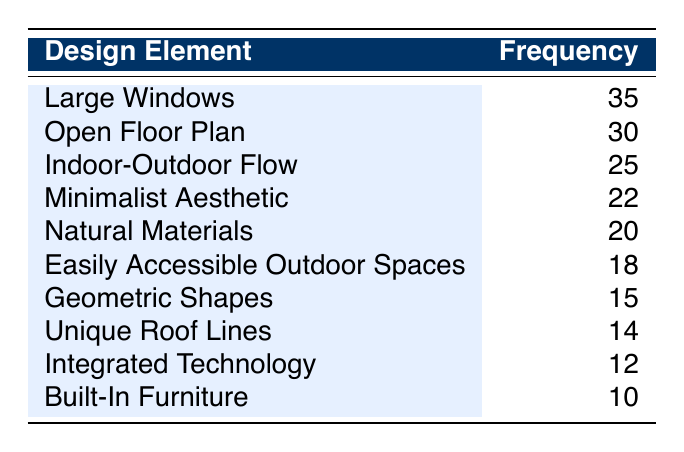What is the frequency of the design element "Large Windows"? The table shows that "Large Windows" has a frequency of 35, which is stated directly in the relevant row.
Answer: 35 Which design element has the lowest frequency? By looking at the table, "Built-In Furniture" has the lowest frequency at 10. This is the smallest value in the frequency column.
Answer: Built-In Furniture What is the total frequency of design elements related to openness (Large Windows, Open Floor Plan, Indoor-Outdoor Flow)? To find this total, add the frequencies of the three relevant design elements: 35 (Large Windows) + 30 (Open Floor Plan) + 25 (Indoor-Outdoor Flow) = 90.
Answer: 90 Is "Integrated Technology" more preferred than "Easily Accessible Outdoor Spaces"? The frequency for "Integrated Technology" is 12, and for "Easily Accessible Outdoor Spaces," it is 18. Since 12 is less than 18, the answer is no.
Answer: No What is the average frequency of the design elements in the table? To calculate the average, sum the frequencies: 35 + 30 + 25 + 20 + 18 + 15 + 12 + 10 + 14 + 22 =  201. There are 10 elements, so divide 201 by 10, which gives 20.1.
Answer: 20.1 Which design element's frequency is closest to the median frequency? The frequencies sorted in order are 10, 12, 14, 15, 18, 20, 22, 25, 30, 35. The median is the average of the 5th and 6th values (18 and 20), which is 19. The closest design element is "Natural Materials" with a frequency of 20.
Answer: Natural Materials What percentage of buyers prefer "Open Floor Plan" compared to the total frequency of all elements? First, the total frequency is 201. Then, for "Open Floor Plan," the frequency is 30. The percentage is calculated as (30/201) * 100, which equals approximately 14.93%.
Answer: 14.93% Does the design element "Unique Roof Lines" have a higher preference frequency than "Geometric Shapes"? "Unique Roof Lines" has a frequency of 14 and "Geometric Shapes" has a frequency of 15. Since 14 is less than 15, the answer is no.
Answer: No 